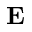<formula> <loc_0><loc_0><loc_500><loc_500>E</formula> 